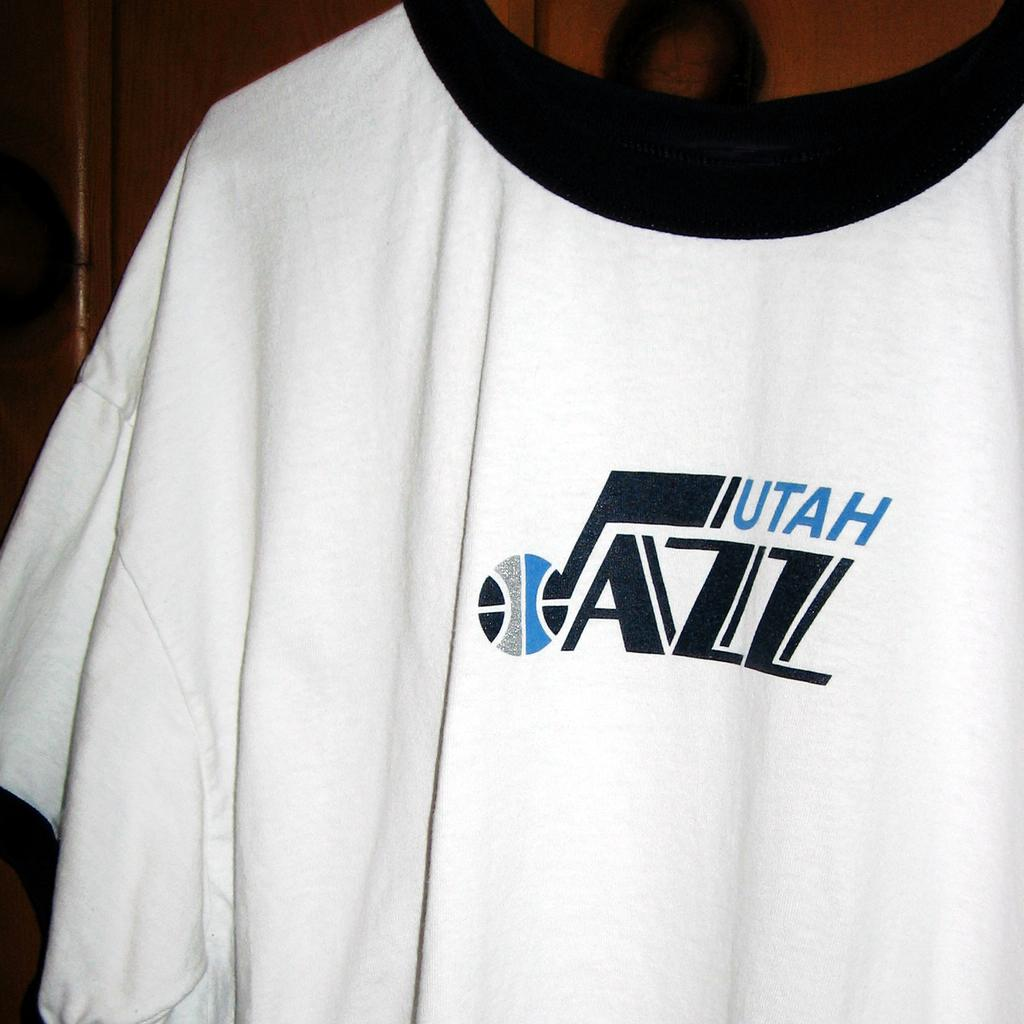<image>
Render a clear and concise summary of the photo. A tee shirt extra large in white with Jazz Utah logo. 